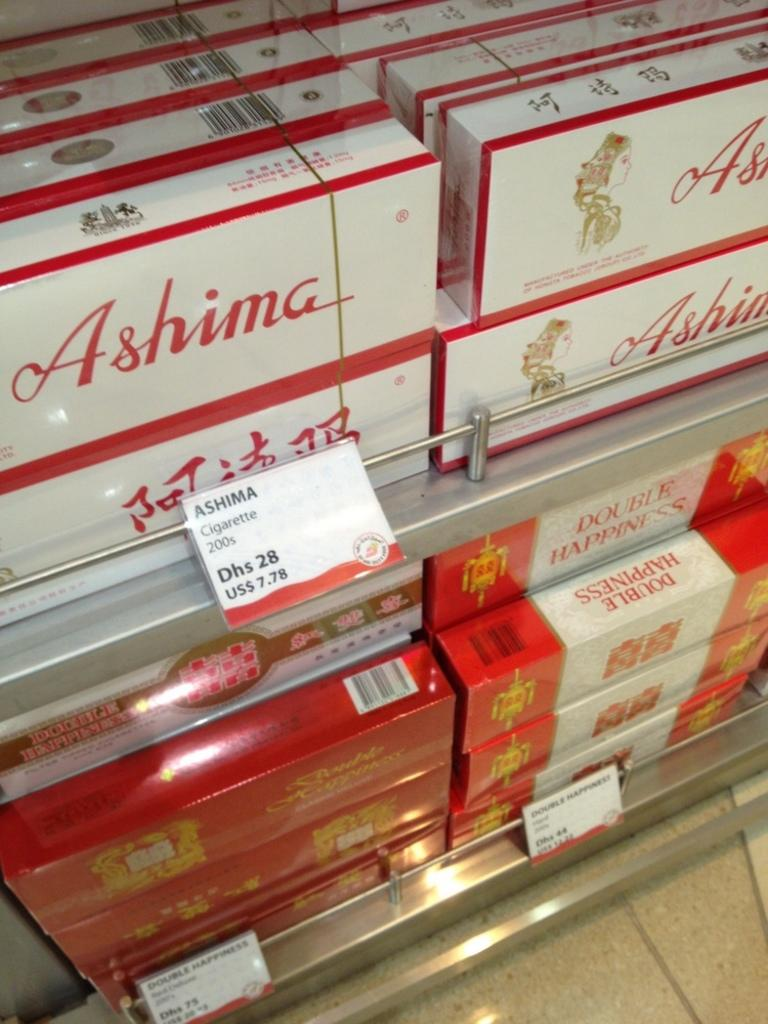<image>
Offer a succinct explanation of the picture presented. Boxes of Ashima cigarettes are shelved and sticker-priced at $7.78. 